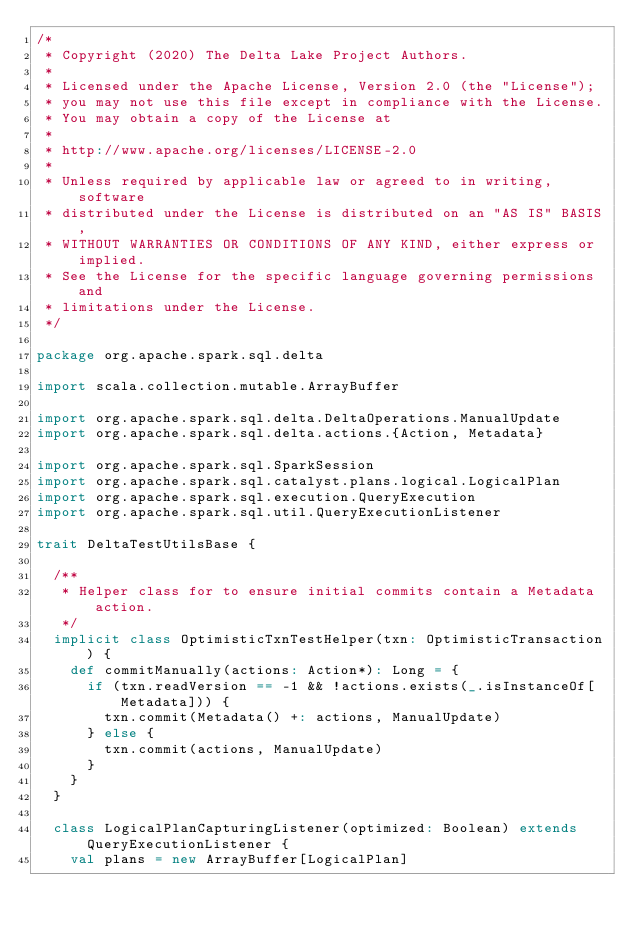<code> <loc_0><loc_0><loc_500><loc_500><_Scala_>/*
 * Copyright (2020) The Delta Lake Project Authors.
 *
 * Licensed under the Apache License, Version 2.0 (the "License");
 * you may not use this file except in compliance with the License.
 * You may obtain a copy of the License at
 *
 * http://www.apache.org/licenses/LICENSE-2.0
 *
 * Unless required by applicable law or agreed to in writing, software
 * distributed under the License is distributed on an "AS IS" BASIS,
 * WITHOUT WARRANTIES OR CONDITIONS OF ANY KIND, either express or implied.
 * See the License for the specific language governing permissions and
 * limitations under the License.
 */

package org.apache.spark.sql.delta

import scala.collection.mutable.ArrayBuffer

import org.apache.spark.sql.delta.DeltaOperations.ManualUpdate
import org.apache.spark.sql.delta.actions.{Action, Metadata}

import org.apache.spark.sql.SparkSession
import org.apache.spark.sql.catalyst.plans.logical.LogicalPlan
import org.apache.spark.sql.execution.QueryExecution
import org.apache.spark.sql.util.QueryExecutionListener

trait DeltaTestUtilsBase {

  /**
   * Helper class for to ensure initial commits contain a Metadata action.
   */
  implicit class OptimisticTxnTestHelper(txn: OptimisticTransaction) {
    def commitManually(actions: Action*): Long = {
      if (txn.readVersion == -1 && !actions.exists(_.isInstanceOf[Metadata])) {
        txn.commit(Metadata() +: actions, ManualUpdate)
      } else {
        txn.commit(actions, ManualUpdate)
      }
    }
  }

  class LogicalPlanCapturingListener(optimized: Boolean) extends QueryExecutionListener {
    val plans = new ArrayBuffer[LogicalPlan]</code> 